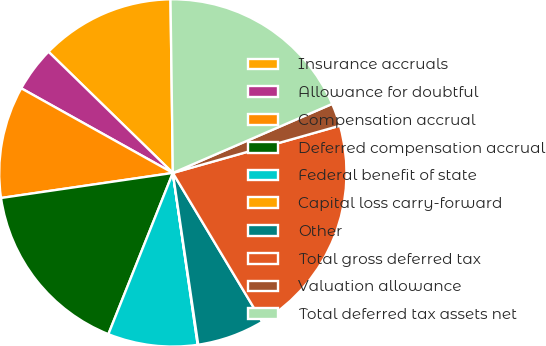<chart> <loc_0><loc_0><loc_500><loc_500><pie_chart><fcel>Insurance accruals<fcel>Allowance for doubtful<fcel>Compensation accrual<fcel>Deferred compensation accrual<fcel>Federal benefit of state<fcel>Capital loss carry-forward<fcel>Other<fcel>Total gross deferred tax<fcel>Valuation allowance<fcel>Total deferred tax assets net<nl><fcel>12.49%<fcel>4.19%<fcel>10.41%<fcel>16.64%<fcel>8.34%<fcel>0.05%<fcel>6.27%<fcel>20.78%<fcel>2.12%<fcel>18.71%<nl></chart> 